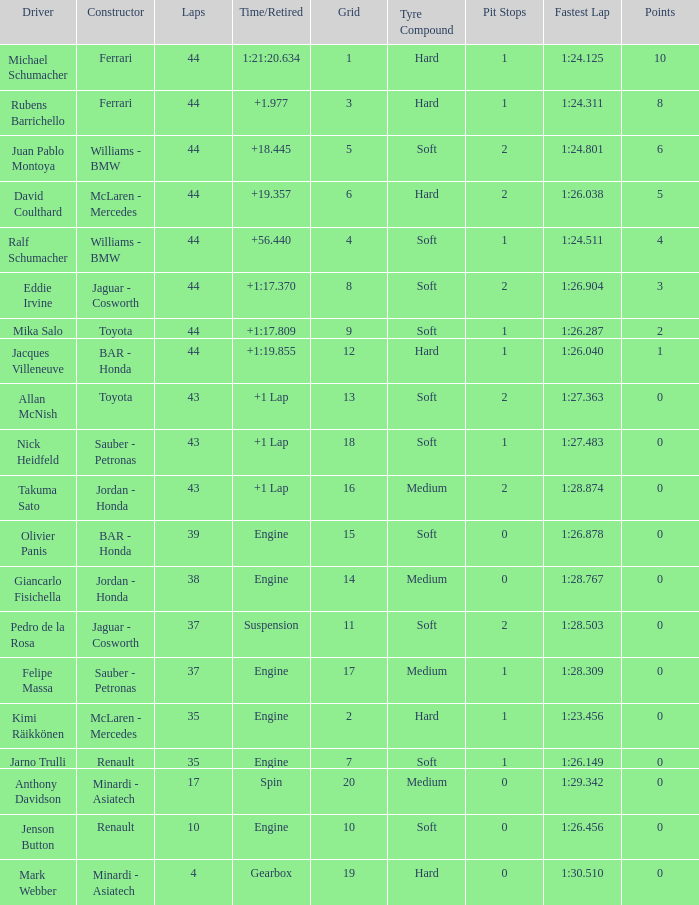What was the retired time on someone who had 43 laps on a grip of 18? +1 Lap. 